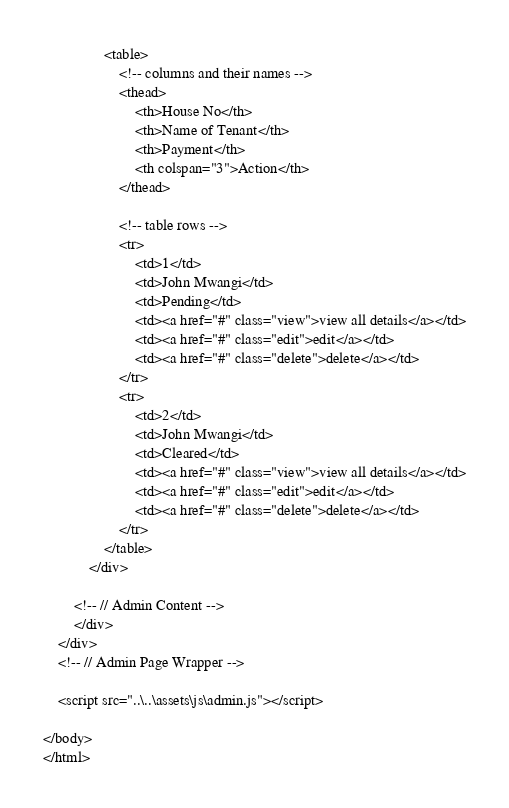Convert code to text. <code><loc_0><loc_0><loc_500><loc_500><_PHP_>                <table>
                    <!-- columns and their names -->
                    <thead>
                        <th>House No</th>
                        <th>Name of Tenant</th>
                        <th>Payment</th>
                        <th colspan="3">Action</th>
                    </thead>

                    <!-- table rows -->
                    <tr>
                        <td>1</td>
                        <td>John Mwangi</td>
                        <td>Pending</td>
                        <td><a href="#" class="view">view all details</a></td>
                        <td><a href="#" class="edit">edit</a></td>
                        <td><a href="#" class="delete">delete</a></td>    
                    </tr>
                    <tr>
                        <td>2</td>
                        <td>John Mwangi</td>
                        <td>Cleared</td>
                        <td><a href="#" class="view">view all details</a></td>
                        <td><a href="#" class="edit">edit</a></td>
                        <td><a href="#" class="delete">delete</a></td>
                    </tr>
                </table>
            </div>
            
        <!-- // Admin Content -->
        </div>
    </div>
    <!-- // Admin Page Wrapper -->

    <script src="..\..\assets\js\admin.js"></script>

</body>
</html></code> 